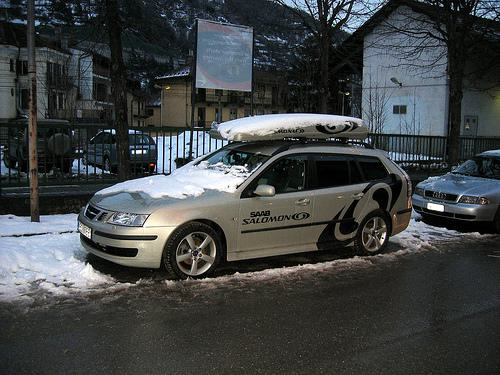Describe the environment around the car. The image shows a car parked on a snowy street, surrounded by buildings with traditional architecture, likely in an urban area experiencing winter. A faint sign and the street's wet, slushy conditions suggest recent snowfall. 